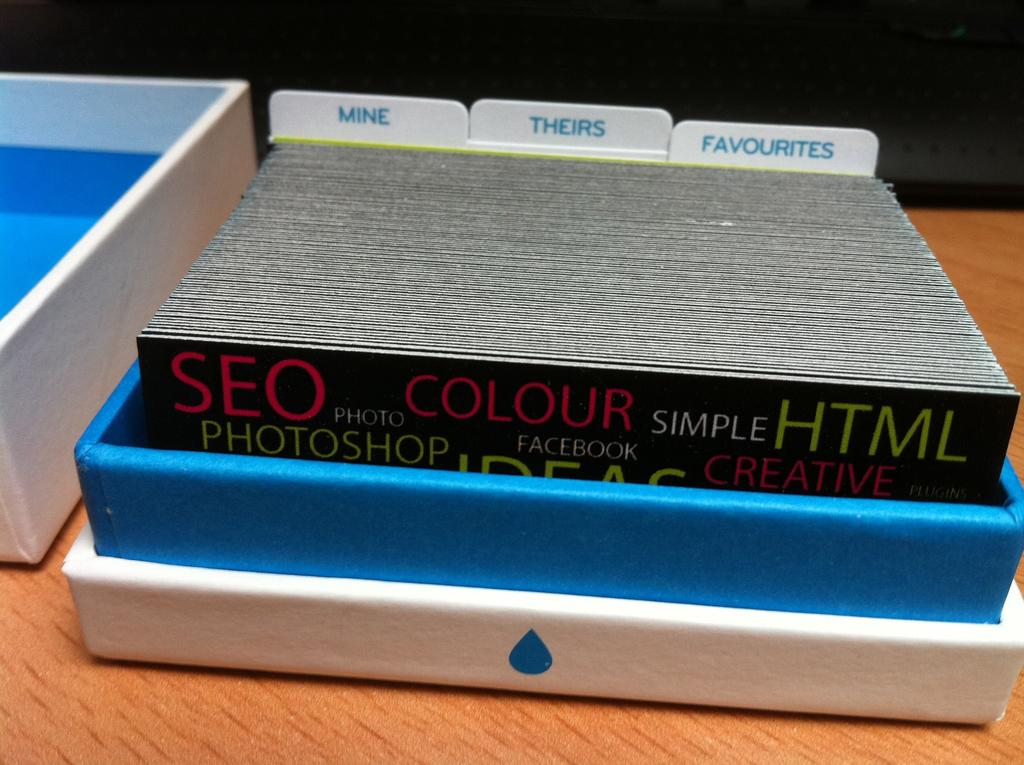<image>
Relay a brief, clear account of the picture shown. the word colour is on the black item 